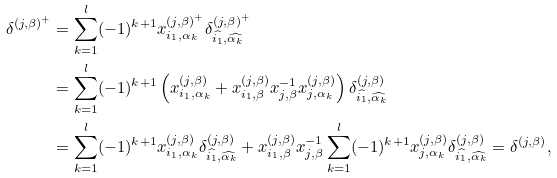<formula> <loc_0><loc_0><loc_500><loc_500>\delta ^ { ( j , \beta ) ^ { + } } & = \sum _ { k = 1 } ^ { l } ( - 1 ) ^ { k + 1 } x _ { i _ { 1 } , \alpha _ { k } } ^ { ( j , \beta ) ^ { + } } \delta _ { \widehat { i _ { 1 } } , \widehat { \alpha _ { k } } } ^ { ( j , \beta ) ^ { + } } \\ & = \sum _ { k = 1 } ^ { l } ( - 1 ) ^ { k + 1 } \left ( x _ { i _ { 1 } , \alpha _ { k } } ^ { ( j , \beta ) } + x _ { i _ { 1 } , \beta } ^ { ( j , \beta ) } x _ { j , \beta } ^ { - 1 } x _ { j , \alpha _ { k } } ^ { ( j , \beta ) } \right ) \delta _ { \widehat { i _ { 1 } } , \widehat { \alpha _ { k } } } ^ { ( j , \beta ) } \\ & = \sum _ { k = 1 } ^ { l } ( - 1 ) ^ { k + 1 } x _ { i _ { 1 } , \alpha _ { k } } ^ { ( j , \beta ) } \delta _ { \widehat { i _ { 1 } } , \widehat { \alpha _ { k } } } ^ { ( j , \beta ) } + x _ { i _ { 1 } , \beta } ^ { ( j , \beta ) } x _ { j , \beta } ^ { - 1 } \sum _ { k = 1 } ^ { l } ( - 1 ) ^ { k + 1 } x _ { j , \alpha _ { k } } ^ { ( j , \beta ) } \delta _ { \widehat { i _ { 1 } } , \widehat { \alpha _ { k } } } ^ { ( j , \beta ) } = \delta ^ { ( j , \beta ) } ,</formula> 